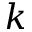Convert formula to latex. <formula><loc_0><loc_0><loc_500><loc_500>k</formula> 